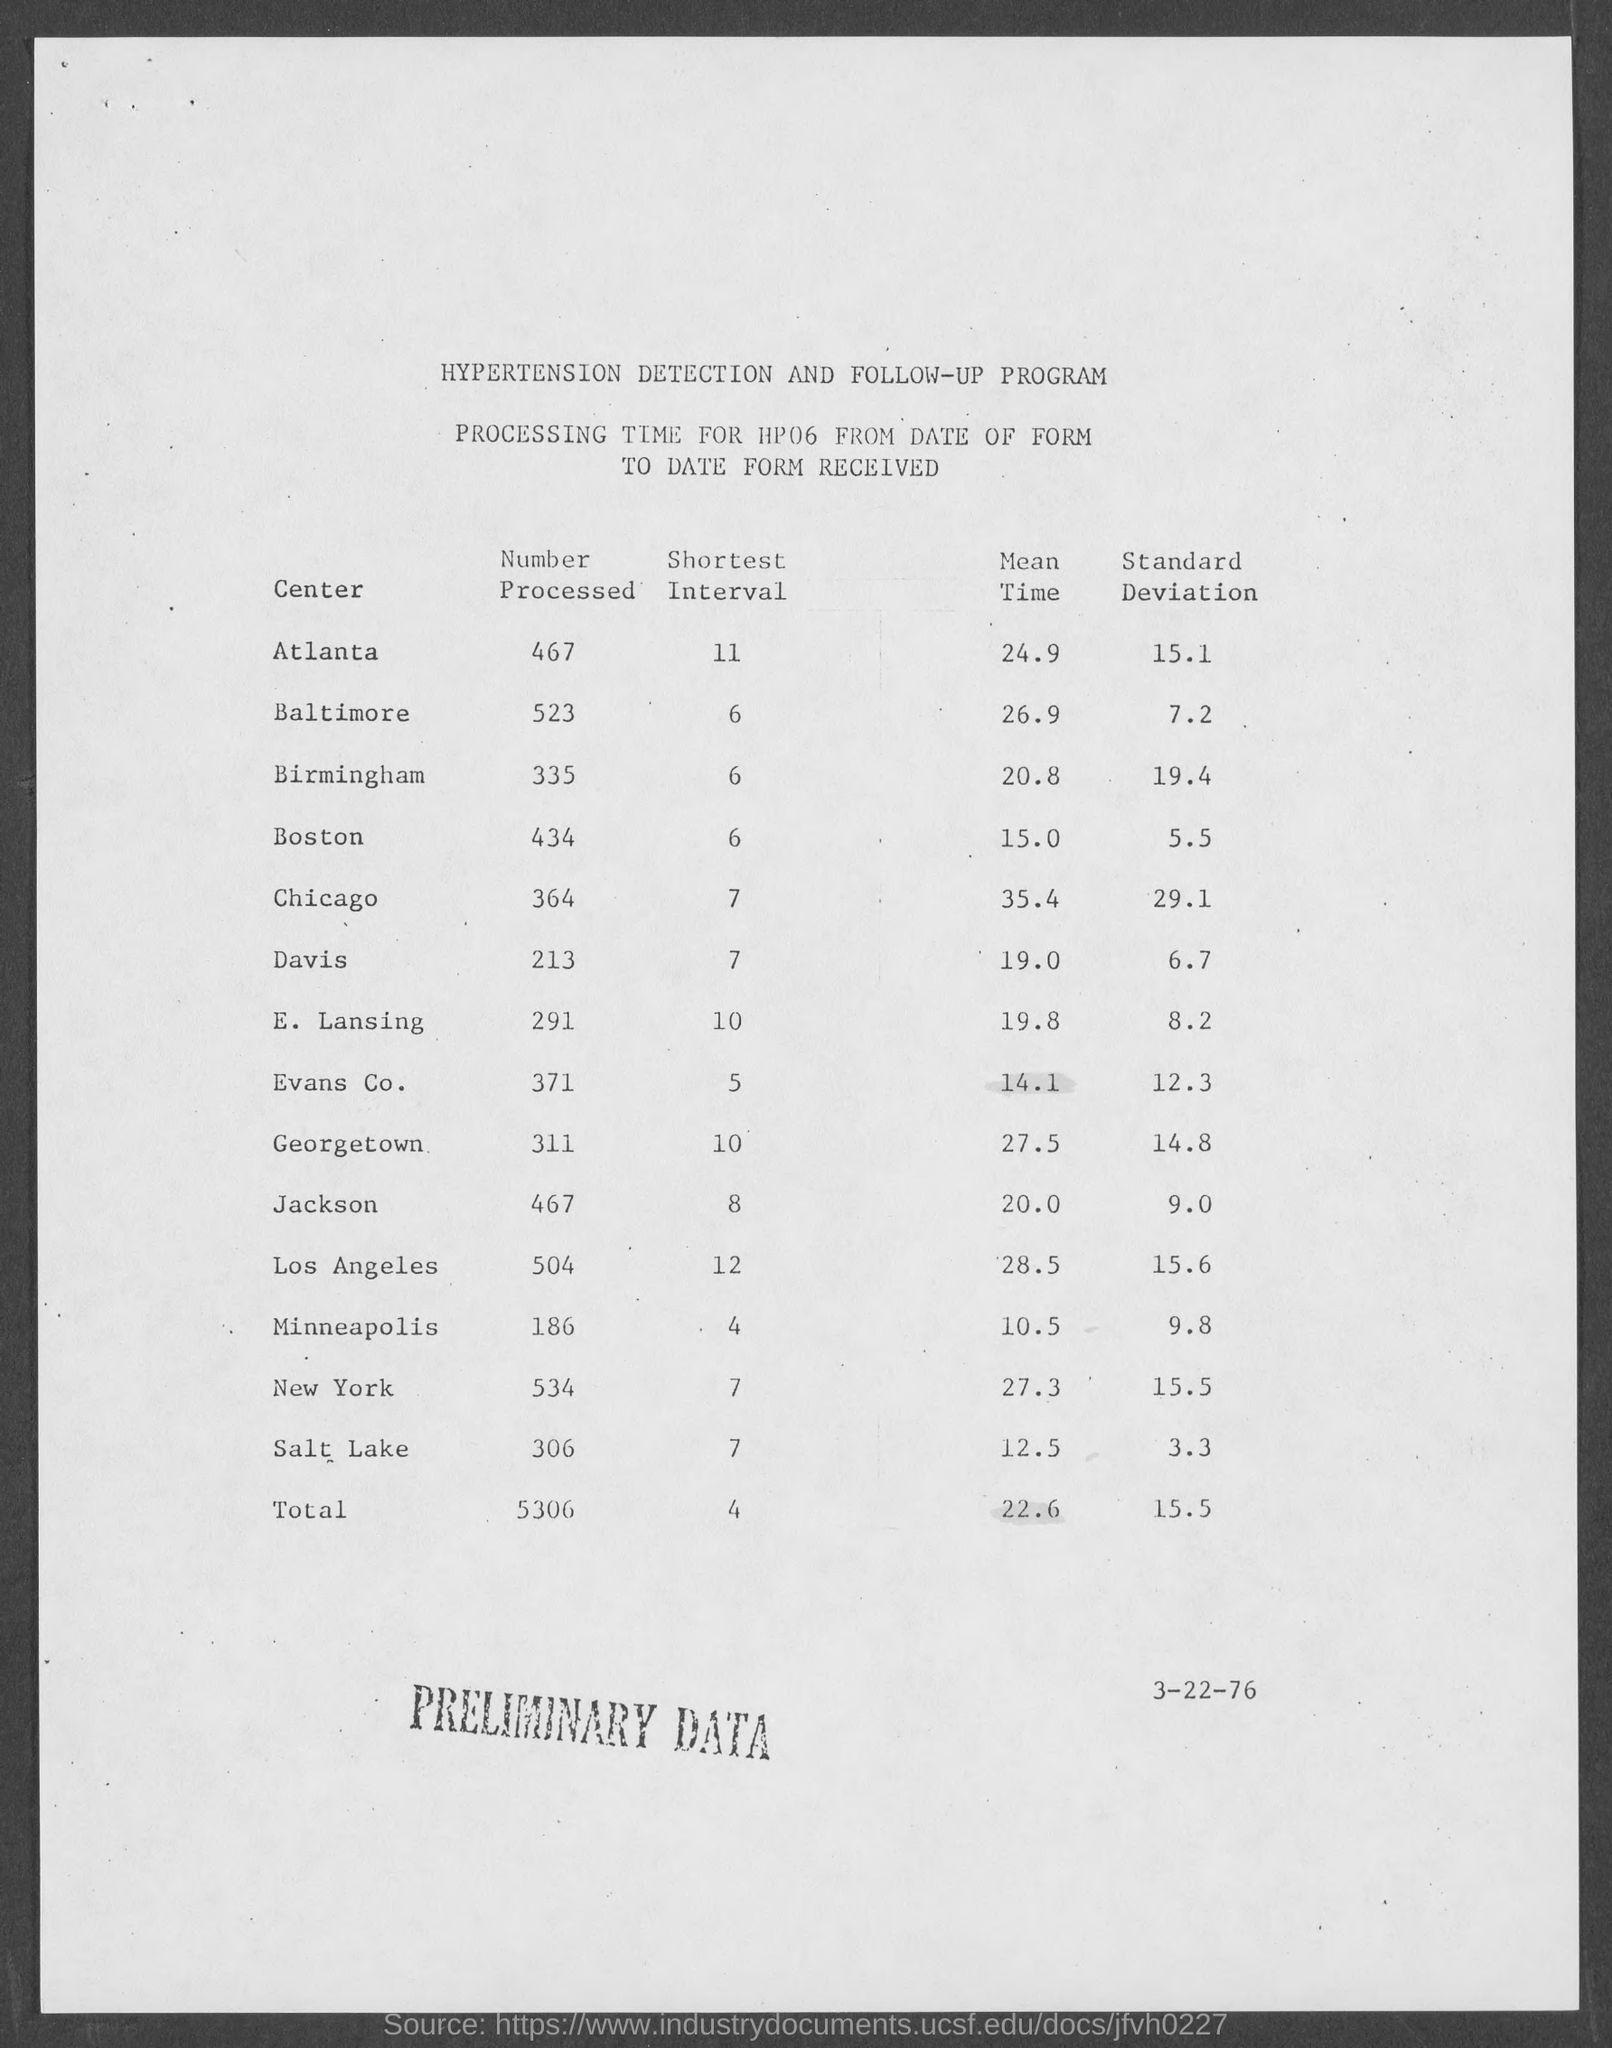Specify some key components in this picture. The shortest interval of Chicago is 7. The shortest interval of New York is from 7 to 7. The total mean time for 22.6 is not specified. The standard deviation for the mean salary of Boston is 5.5. The mean time of Davis is 19 hours and 0 minutes. 